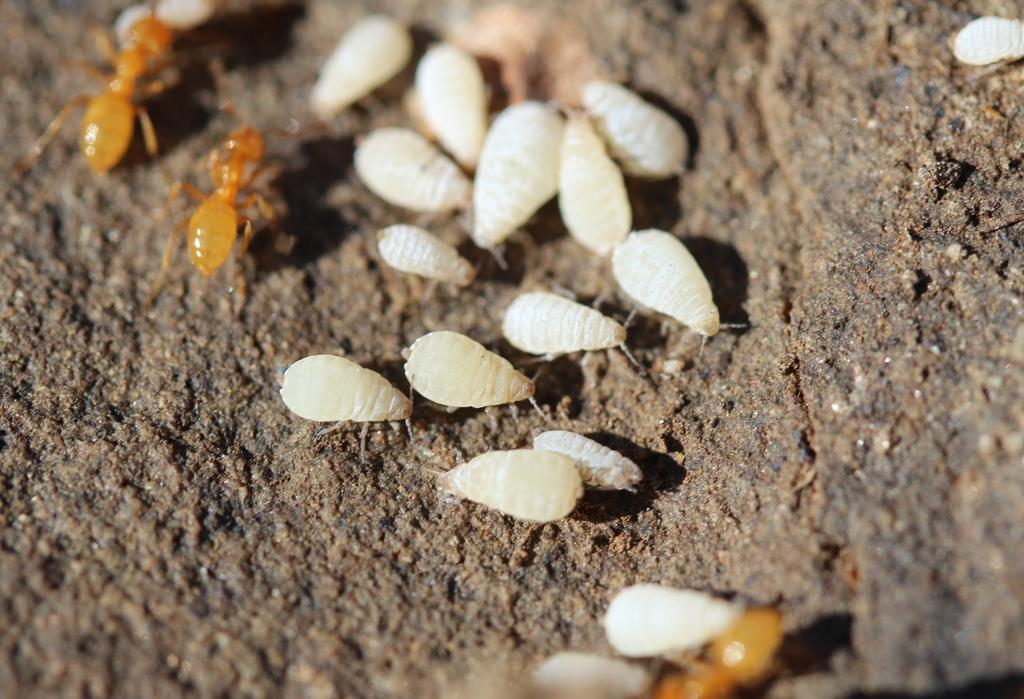What type of creatures are present in the image? There are small insects in the image. Where are the insects located? The insects are on a stone. What type of letter is being delivered by the insects in the image? There is no letter present in the image, and the insects are not delivering anything. 